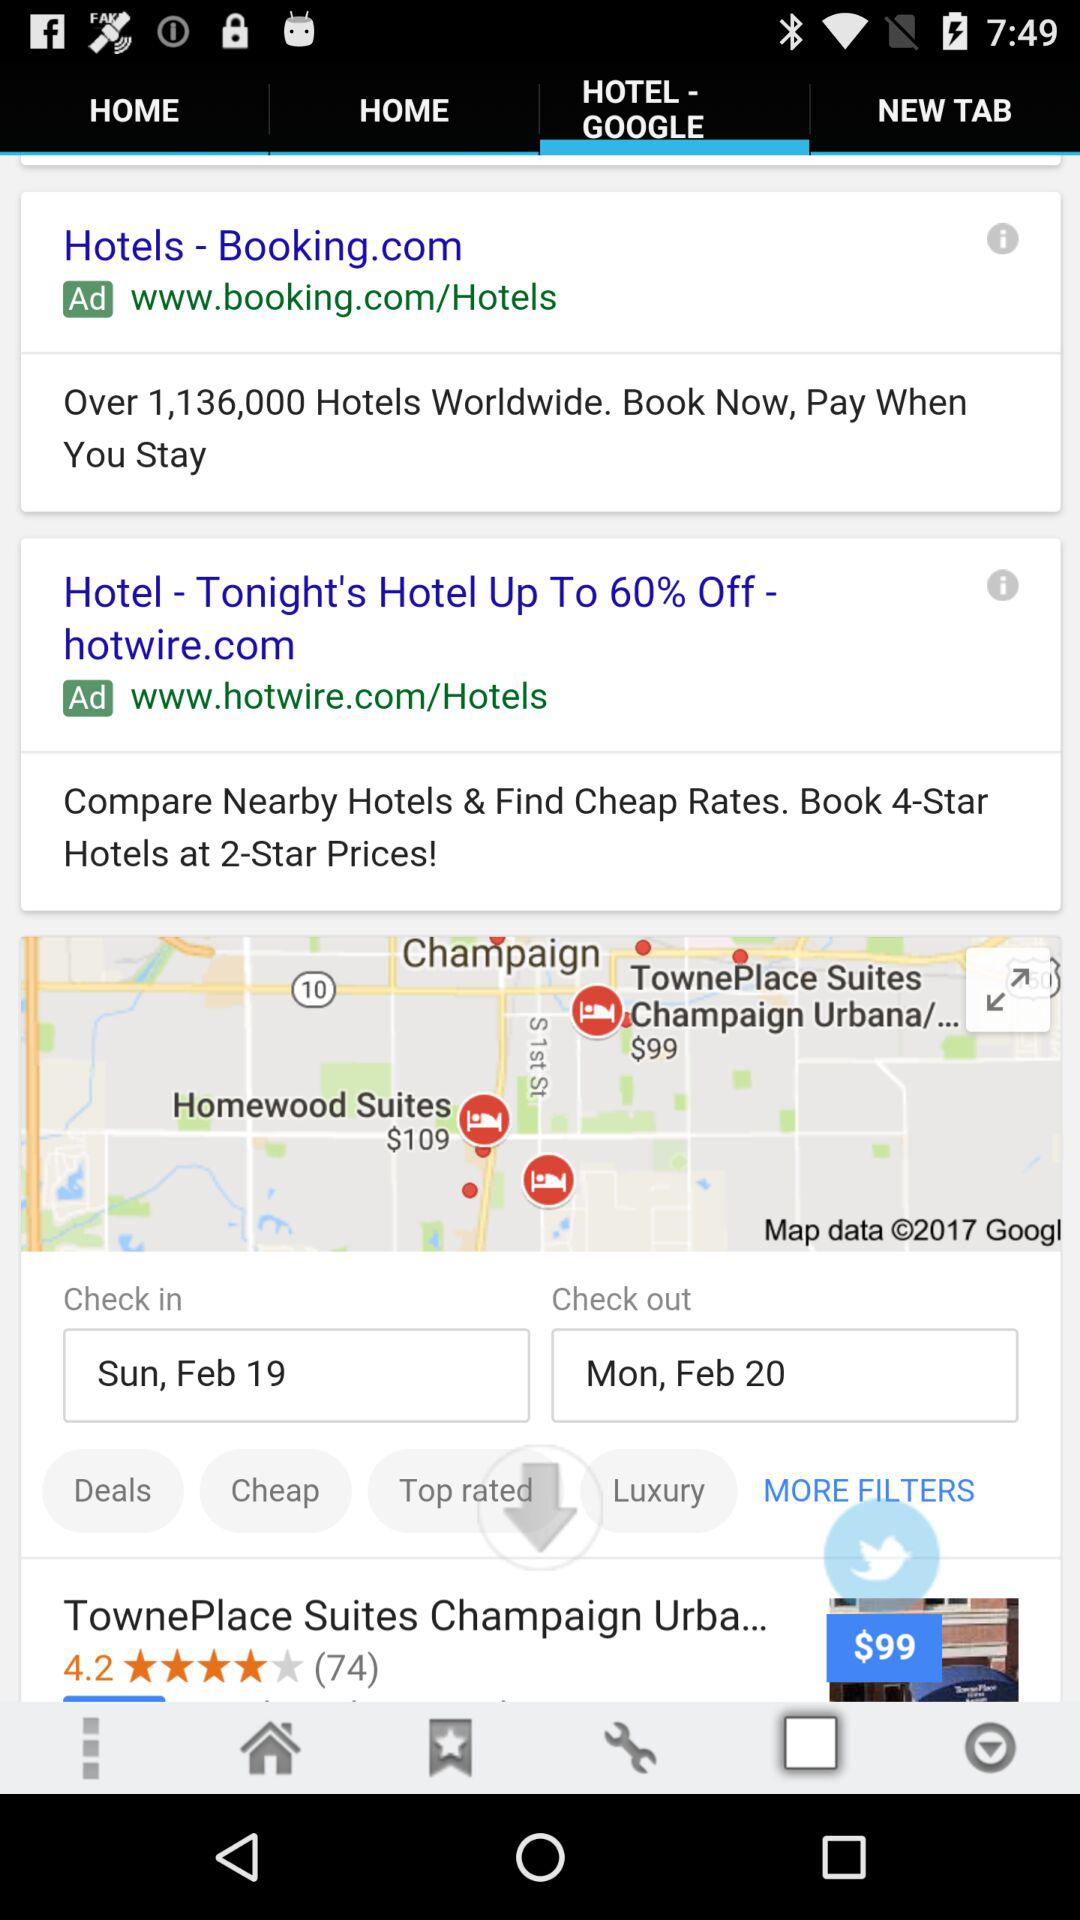How many hotel searches are given worldwide? The number of hotel searches given worldwide is over 1,136,000. 